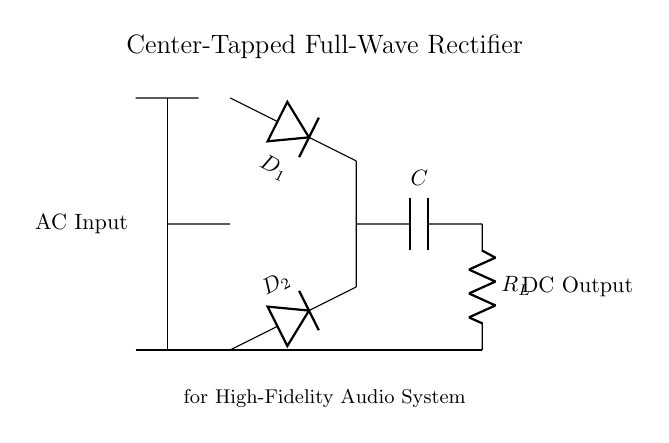What are the two diodes used in this circuit? The circuit diagram labels the diodes as D1 and D2.
Answer: D1, D2 What is the purpose of the capacitor in this rectifier? The capacitor is used for smoothing the DC output, helping to reduce voltage fluctuations after rectification.
Answer: Smoothing Which component connects the AC input to the transformer? The transformer core directly connects the AC input to the secondary winding of the transformer.
Answer: Transformer What type of rectification does this circuit perform? The circuit is designed to perform full-wave rectification using a center-tapped transformer.
Answer: Full-wave How many outputs does the center-tapped configuration provide? A center-tapped transformer provides two outputs from the secondary winding, allowing the diodes to conduct during different halves of the AC cycle.
Answer: Two What load is indicated in the circuit? The load in the circuit is labeled as R_L, which typically represents the resistive load connected to the DC output.
Answer: R_L What is the DC output voltage relative to the AC input? The DC output will be approximately the peak voltage of the AC input minus diode drops; this typically is not explicitly shown in the diagram but can be inferred.
Answer: Peak voltage minus diode drops 